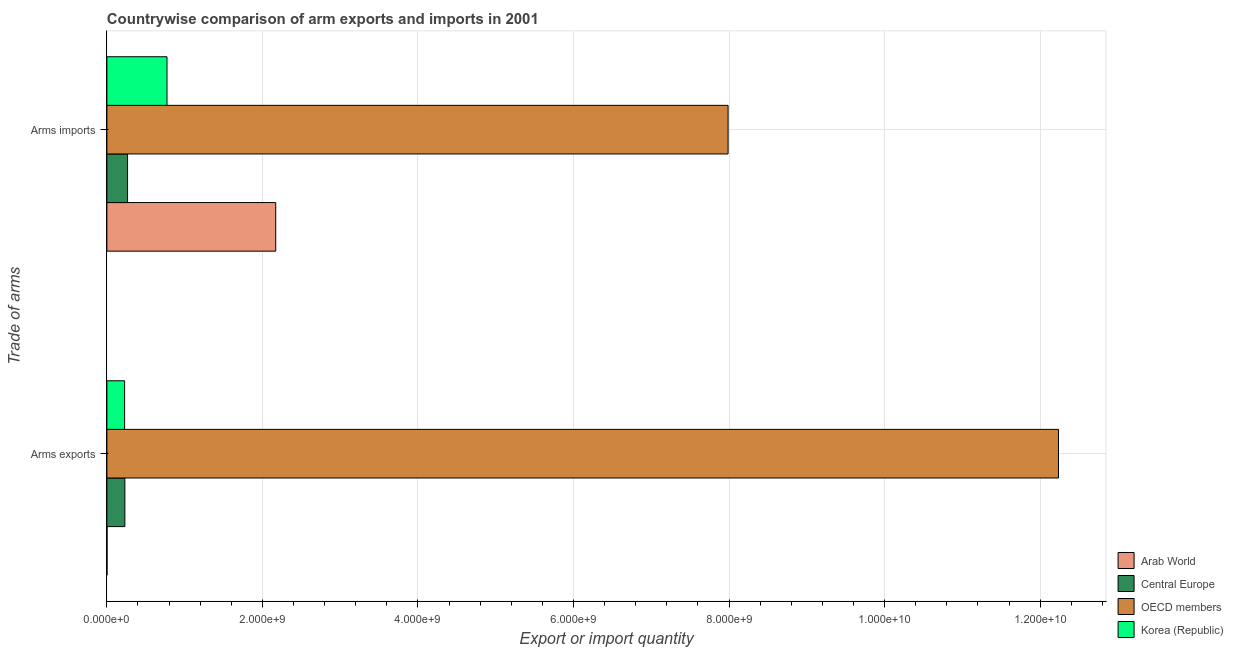How many different coloured bars are there?
Your answer should be very brief. 4. How many groups of bars are there?
Offer a terse response. 2. Are the number of bars per tick equal to the number of legend labels?
Offer a very short reply. Yes. Are the number of bars on each tick of the Y-axis equal?
Provide a succinct answer. Yes. How many bars are there on the 1st tick from the top?
Give a very brief answer. 4. What is the label of the 1st group of bars from the top?
Your response must be concise. Arms imports. What is the arms exports in Arab World?
Provide a succinct answer. 2.00e+06. Across all countries, what is the maximum arms exports?
Make the answer very short. 1.22e+1. Across all countries, what is the minimum arms imports?
Your answer should be compact. 2.66e+08. In which country was the arms imports minimum?
Keep it short and to the point. Central Europe. What is the total arms imports in the graph?
Your answer should be very brief. 1.12e+1. What is the difference between the arms imports in OECD members and that in Arab World?
Offer a very short reply. 5.82e+09. What is the difference between the arms exports in OECD members and the arms imports in Arab World?
Provide a short and direct response. 1.01e+1. What is the average arms imports per country?
Give a very brief answer. 2.80e+09. What is the difference between the arms exports and arms imports in OECD members?
Make the answer very short. 4.25e+09. In how many countries, is the arms exports greater than 4800000000 ?
Offer a terse response. 1. What is the ratio of the arms imports in Central Europe to that in OECD members?
Provide a short and direct response. 0.03. Is the arms exports in Arab World less than that in Central Europe?
Your answer should be compact. Yes. In how many countries, is the arms imports greater than the average arms imports taken over all countries?
Make the answer very short. 1. What does the 1st bar from the bottom in Arms exports represents?
Your answer should be very brief. Arab World. How many bars are there?
Make the answer very short. 8. Does the graph contain grids?
Offer a terse response. Yes. Where does the legend appear in the graph?
Offer a very short reply. Bottom right. How many legend labels are there?
Keep it short and to the point. 4. What is the title of the graph?
Provide a succinct answer. Countrywise comparison of arm exports and imports in 2001. Does "Singapore" appear as one of the legend labels in the graph?
Offer a very short reply. No. What is the label or title of the X-axis?
Make the answer very short. Export or import quantity. What is the label or title of the Y-axis?
Offer a terse response. Trade of arms. What is the Export or import quantity of Central Europe in Arms exports?
Provide a short and direct response. 2.31e+08. What is the Export or import quantity of OECD members in Arms exports?
Make the answer very short. 1.22e+1. What is the Export or import quantity in Korea (Republic) in Arms exports?
Offer a very short reply. 2.28e+08. What is the Export or import quantity in Arab World in Arms imports?
Make the answer very short. 2.17e+09. What is the Export or import quantity in Central Europe in Arms imports?
Your answer should be compact. 2.66e+08. What is the Export or import quantity of OECD members in Arms imports?
Your response must be concise. 7.99e+09. What is the Export or import quantity of Korea (Republic) in Arms imports?
Keep it short and to the point. 7.73e+08. Across all Trade of arms, what is the maximum Export or import quantity in Arab World?
Provide a succinct answer. 2.17e+09. Across all Trade of arms, what is the maximum Export or import quantity in Central Europe?
Your answer should be very brief. 2.66e+08. Across all Trade of arms, what is the maximum Export or import quantity in OECD members?
Make the answer very short. 1.22e+1. Across all Trade of arms, what is the maximum Export or import quantity of Korea (Republic)?
Provide a short and direct response. 7.73e+08. Across all Trade of arms, what is the minimum Export or import quantity in Arab World?
Offer a very short reply. 2.00e+06. Across all Trade of arms, what is the minimum Export or import quantity in Central Europe?
Provide a succinct answer. 2.31e+08. Across all Trade of arms, what is the minimum Export or import quantity in OECD members?
Provide a short and direct response. 7.99e+09. Across all Trade of arms, what is the minimum Export or import quantity in Korea (Republic)?
Give a very brief answer. 2.28e+08. What is the total Export or import quantity in Arab World in the graph?
Provide a short and direct response. 2.17e+09. What is the total Export or import quantity in Central Europe in the graph?
Ensure brevity in your answer.  4.97e+08. What is the total Export or import quantity of OECD members in the graph?
Your answer should be very brief. 2.02e+1. What is the total Export or import quantity in Korea (Republic) in the graph?
Offer a very short reply. 1.00e+09. What is the difference between the Export or import quantity of Arab World in Arms exports and that in Arms imports?
Keep it short and to the point. -2.17e+09. What is the difference between the Export or import quantity of Central Europe in Arms exports and that in Arms imports?
Offer a very short reply. -3.50e+07. What is the difference between the Export or import quantity of OECD members in Arms exports and that in Arms imports?
Your answer should be very brief. 4.25e+09. What is the difference between the Export or import quantity of Korea (Republic) in Arms exports and that in Arms imports?
Ensure brevity in your answer.  -5.45e+08. What is the difference between the Export or import quantity of Arab World in Arms exports and the Export or import quantity of Central Europe in Arms imports?
Provide a succinct answer. -2.64e+08. What is the difference between the Export or import quantity of Arab World in Arms exports and the Export or import quantity of OECD members in Arms imports?
Offer a terse response. -7.98e+09. What is the difference between the Export or import quantity in Arab World in Arms exports and the Export or import quantity in Korea (Republic) in Arms imports?
Provide a succinct answer. -7.71e+08. What is the difference between the Export or import quantity of Central Europe in Arms exports and the Export or import quantity of OECD members in Arms imports?
Provide a short and direct response. -7.76e+09. What is the difference between the Export or import quantity of Central Europe in Arms exports and the Export or import quantity of Korea (Republic) in Arms imports?
Your answer should be compact. -5.42e+08. What is the difference between the Export or import quantity in OECD members in Arms exports and the Export or import quantity in Korea (Republic) in Arms imports?
Provide a succinct answer. 1.15e+1. What is the average Export or import quantity in Arab World per Trade of arms?
Keep it short and to the point. 1.09e+09. What is the average Export or import quantity in Central Europe per Trade of arms?
Your answer should be very brief. 2.48e+08. What is the average Export or import quantity of OECD members per Trade of arms?
Keep it short and to the point. 1.01e+1. What is the average Export or import quantity in Korea (Republic) per Trade of arms?
Your answer should be compact. 5.00e+08. What is the difference between the Export or import quantity of Arab World and Export or import quantity of Central Europe in Arms exports?
Keep it short and to the point. -2.29e+08. What is the difference between the Export or import quantity in Arab World and Export or import quantity in OECD members in Arms exports?
Ensure brevity in your answer.  -1.22e+1. What is the difference between the Export or import quantity in Arab World and Export or import quantity in Korea (Republic) in Arms exports?
Provide a succinct answer. -2.26e+08. What is the difference between the Export or import quantity of Central Europe and Export or import quantity of OECD members in Arms exports?
Your answer should be compact. -1.20e+1. What is the difference between the Export or import quantity of Central Europe and Export or import quantity of Korea (Republic) in Arms exports?
Provide a short and direct response. 3.00e+06. What is the difference between the Export or import quantity of OECD members and Export or import quantity of Korea (Republic) in Arms exports?
Your answer should be very brief. 1.20e+1. What is the difference between the Export or import quantity of Arab World and Export or import quantity of Central Europe in Arms imports?
Your answer should be compact. 1.90e+09. What is the difference between the Export or import quantity of Arab World and Export or import quantity of OECD members in Arms imports?
Your answer should be very brief. -5.82e+09. What is the difference between the Export or import quantity in Arab World and Export or import quantity in Korea (Republic) in Arms imports?
Keep it short and to the point. 1.40e+09. What is the difference between the Export or import quantity in Central Europe and Export or import quantity in OECD members in Arms imports?
Your response must be concise. -7.72e+09. What is the difference between the Export or import quantity of Central Europe and Export or import quantity of Korea (Republic) in Arms imports?
Your answer should be compact. -5.07e+08. What is the difference between the Export or import quantity in OECD members and Export or import quantity in Korea (Republic) in Arms imports?
Make the answer very short. 7.21e+09. What is the ratio of the Export or import quantity of Arab World in Arms exports to that in Arms imports?
Offer a very short reply. 0. What is the ratio of the Export or import quantity in Central Europe in Arms exports to that in Arms imports?
Offer a terse response. 0.87. What is the ratio of the Export or import quantity of OECD members in Arms exports to that in Arms imports?
Make the answer very short. 1.53. What is the ratio of the Export or import quantity in Korea (Republic) in Arms exports to that in Arms imports?
Offer a terse response. 0.29. What is the difference between the highest and the second highest Export or import quantity in Arab World?
Provide a succinct answer. 2.17e+09. What is the difference between the highest and the second highest Export or import quantity of Central Europe?
Keep it short and to the point. 3.50e+07. What is the difference between the highest and the second highest Export or import quantity in OECD members?
Give a very brief answer. 4.25e+09. What is the difference between the highest and the second highest Export or import quantity in Korea (Republic)?
Give a very brief answer. 5.45e+08. What is the difference between the highest and the lowest Export or import quantity of Arab World?
Provide a succinct answer. 2.17e+09. What is the difference between the highest and the lowest Export or import quantity of Central Europe?
Ensure brevity in your answer.  3.50e+07. What is the difference between the highest and the lowest Export or import quantity of OECD members?
Make the answer very short. 4.25e+09. What is the difference between the highest and the lowest Export or import quantity of Korea (Republic)?
Provide a succinct answer. 5.45e+08. 